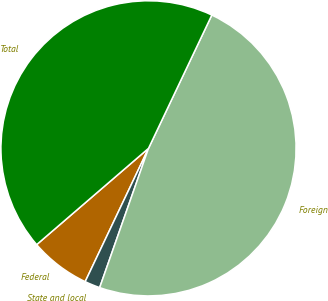<chart> <loc_0><loc_0><loc_500><loc_500><pie_chart><fcel>Federal<fcel>State and local<fcel>Foreign<fcel>Total<nl><fcel>6.63%<fcel>1.69%<fcel>48.31%<fcel>43.37%<nl></chart> 